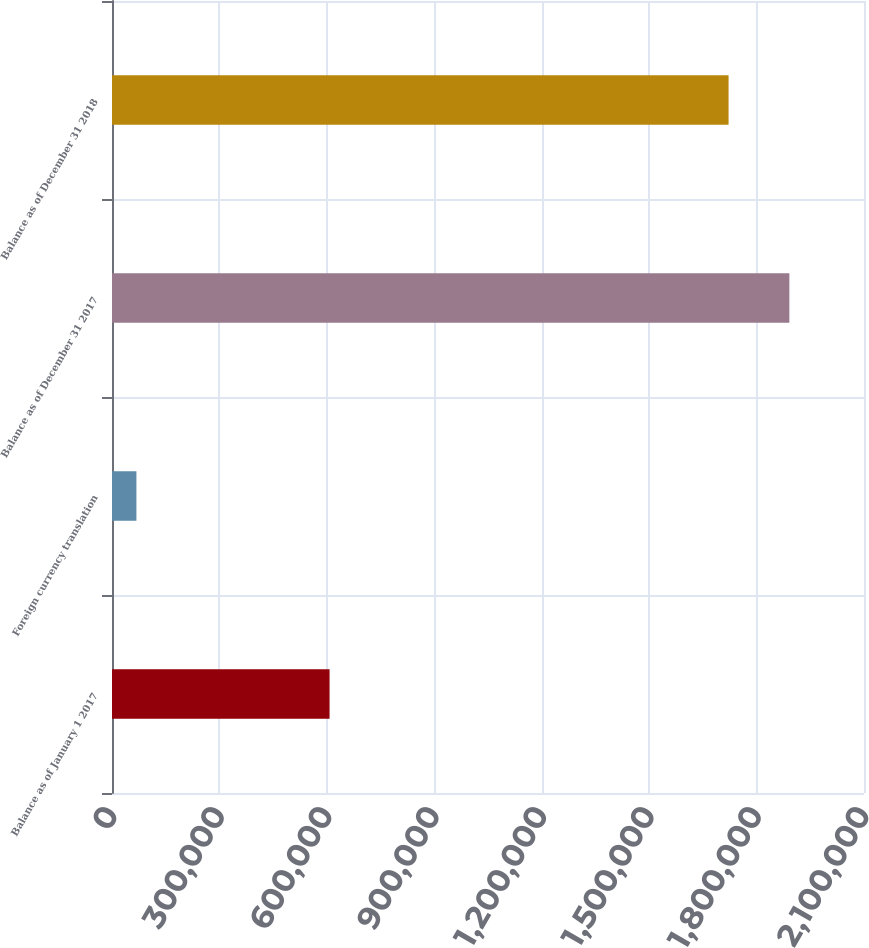<chart> <loc_0><loc_0><loc_500><loc_500><bar_chart><fcel>Balance as of January 1 2017<fcel>Foreign currency translation<fcel>Balance as of December 31 2017<fcel>Balance as of December 31 2018<nl><fcel>607558<fcel>68183<fcel>1.89156e+06<fcel>1.72182e+06<nl></chart> 